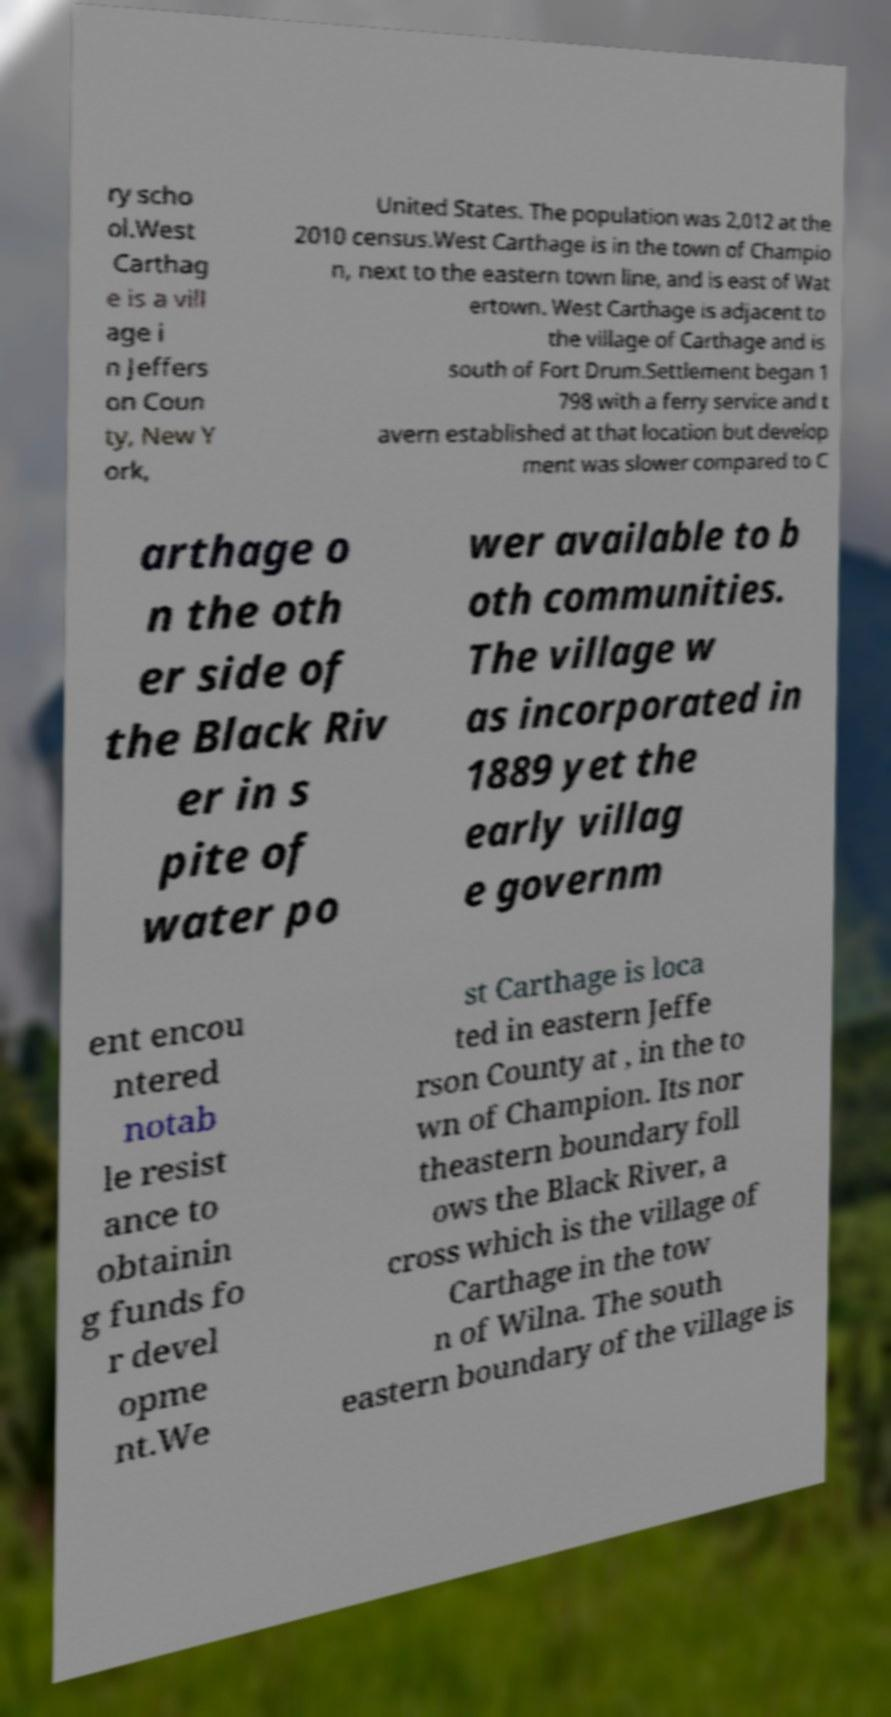I need the written content from this picture converted into text. Can you do that? ry scho ol.West Carthag e is a vill age i n Jeffers on Coun ty, New Y ork, United States. The population was 2,012 at the 2010 census.West Carthage is in the town of Champio n, next to the eastern town line, and is east of Wat ertown. West Carthage is adjacent to the village of Carthage and is south of Fort Drum.Settlement began 1 798 with a ferry service and t avern established at that location but develop ment was slower compared to C arthage o n the oth er side of the Black Riv er in s pite of water po wer available to b oth communities. The village w as incorporated in 1889 yet the early villag e governm ent encou ntered notab le resist ance to obtainin g funds fo r devel opme nt.We st Carthage is loca ted in eastern Jeffe rson County at , in the to wn of Champion. Its nor theastern boundary foll ows the Black River, a cross which is the village of Carthage in the tow n of Wilna. The south eastern boundary of the village is 